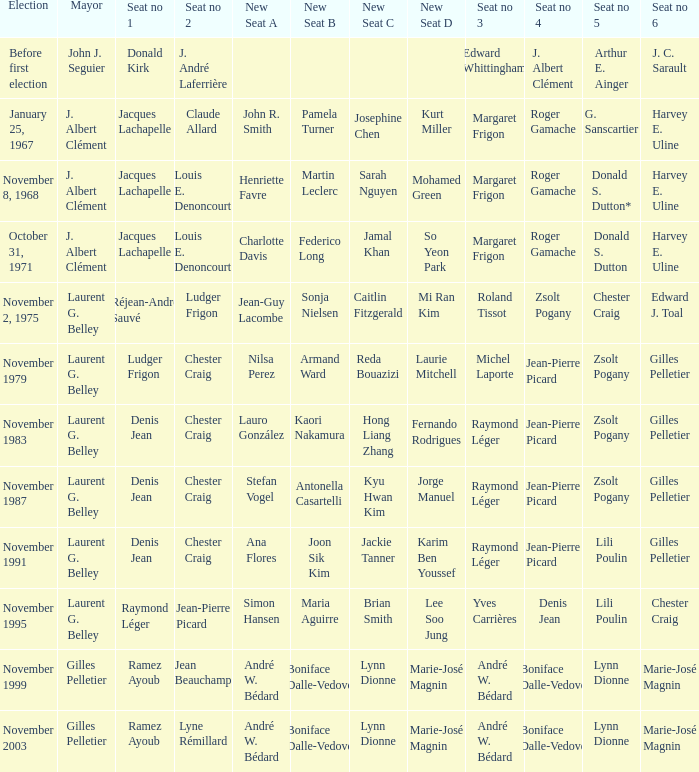Who is seat no 1 when the mayor was john j. seguier Donald Kirk. 